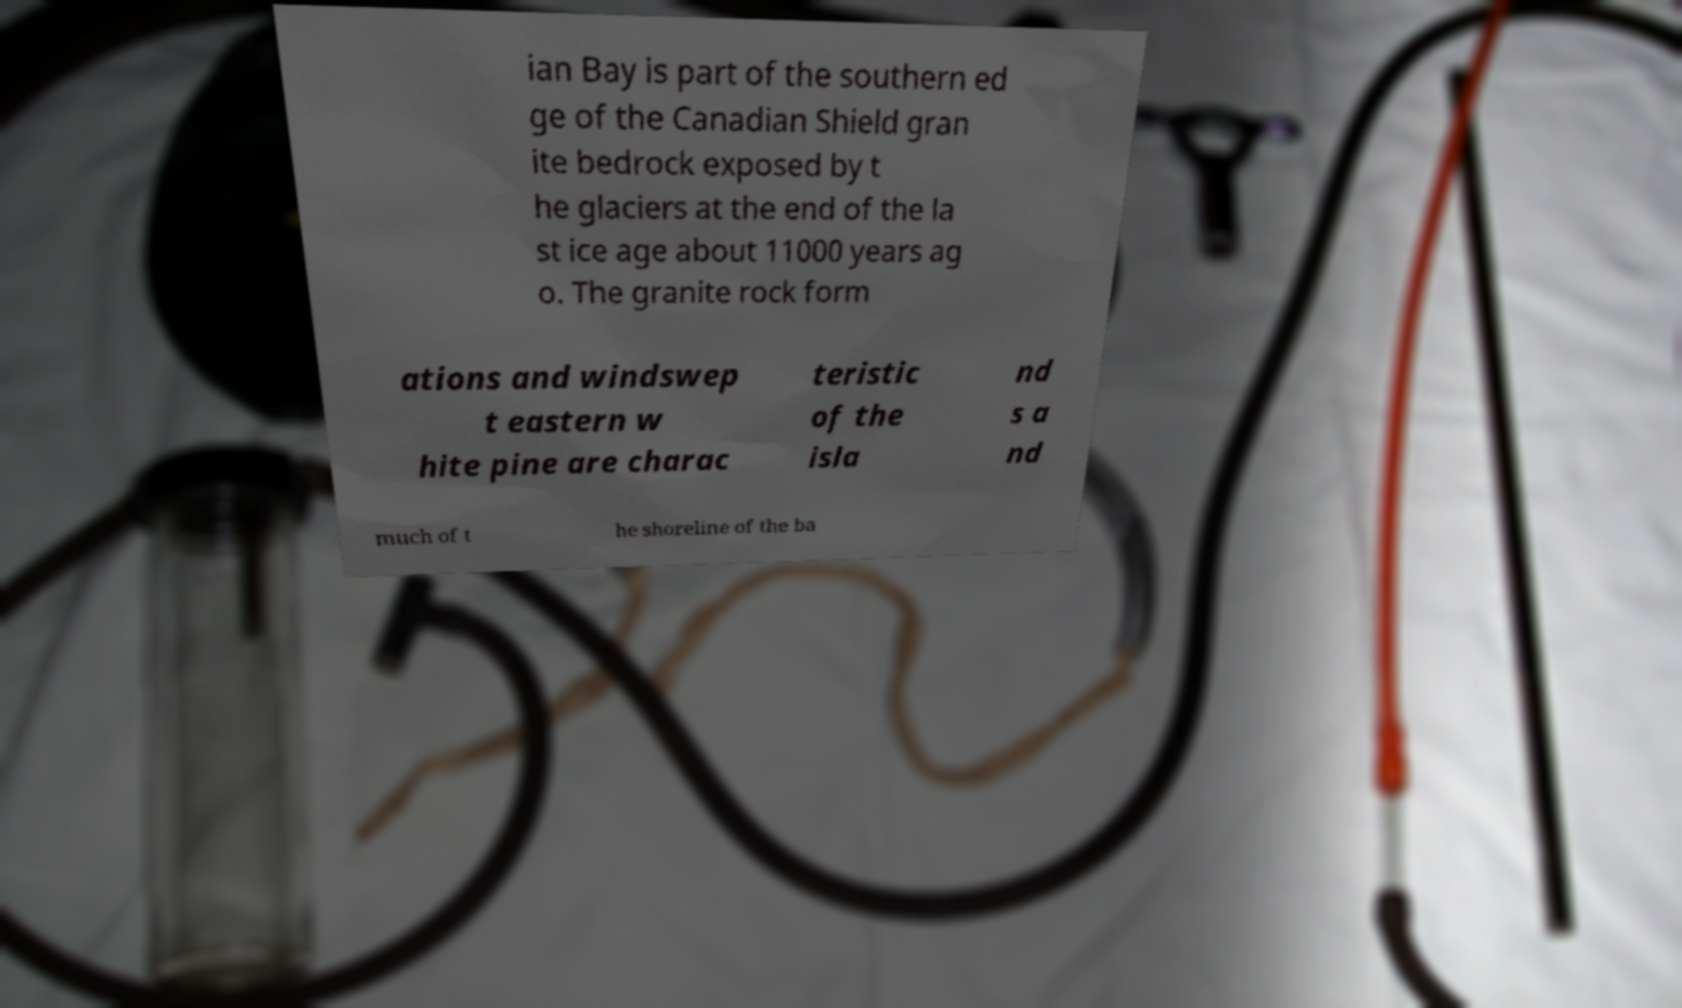Can you accurately transcribe the text from the provided image for me? ian Bay is part of the southern ed ge of the Canadian Shield gran ite bedrock exposed by t he glaciers at the end of the la st ice age about 11000 years ag o. The granite rock form ations and windswep t eastern w hite pine are charac teristic of the isla nd s a nd much of t he shoreline of the ba 